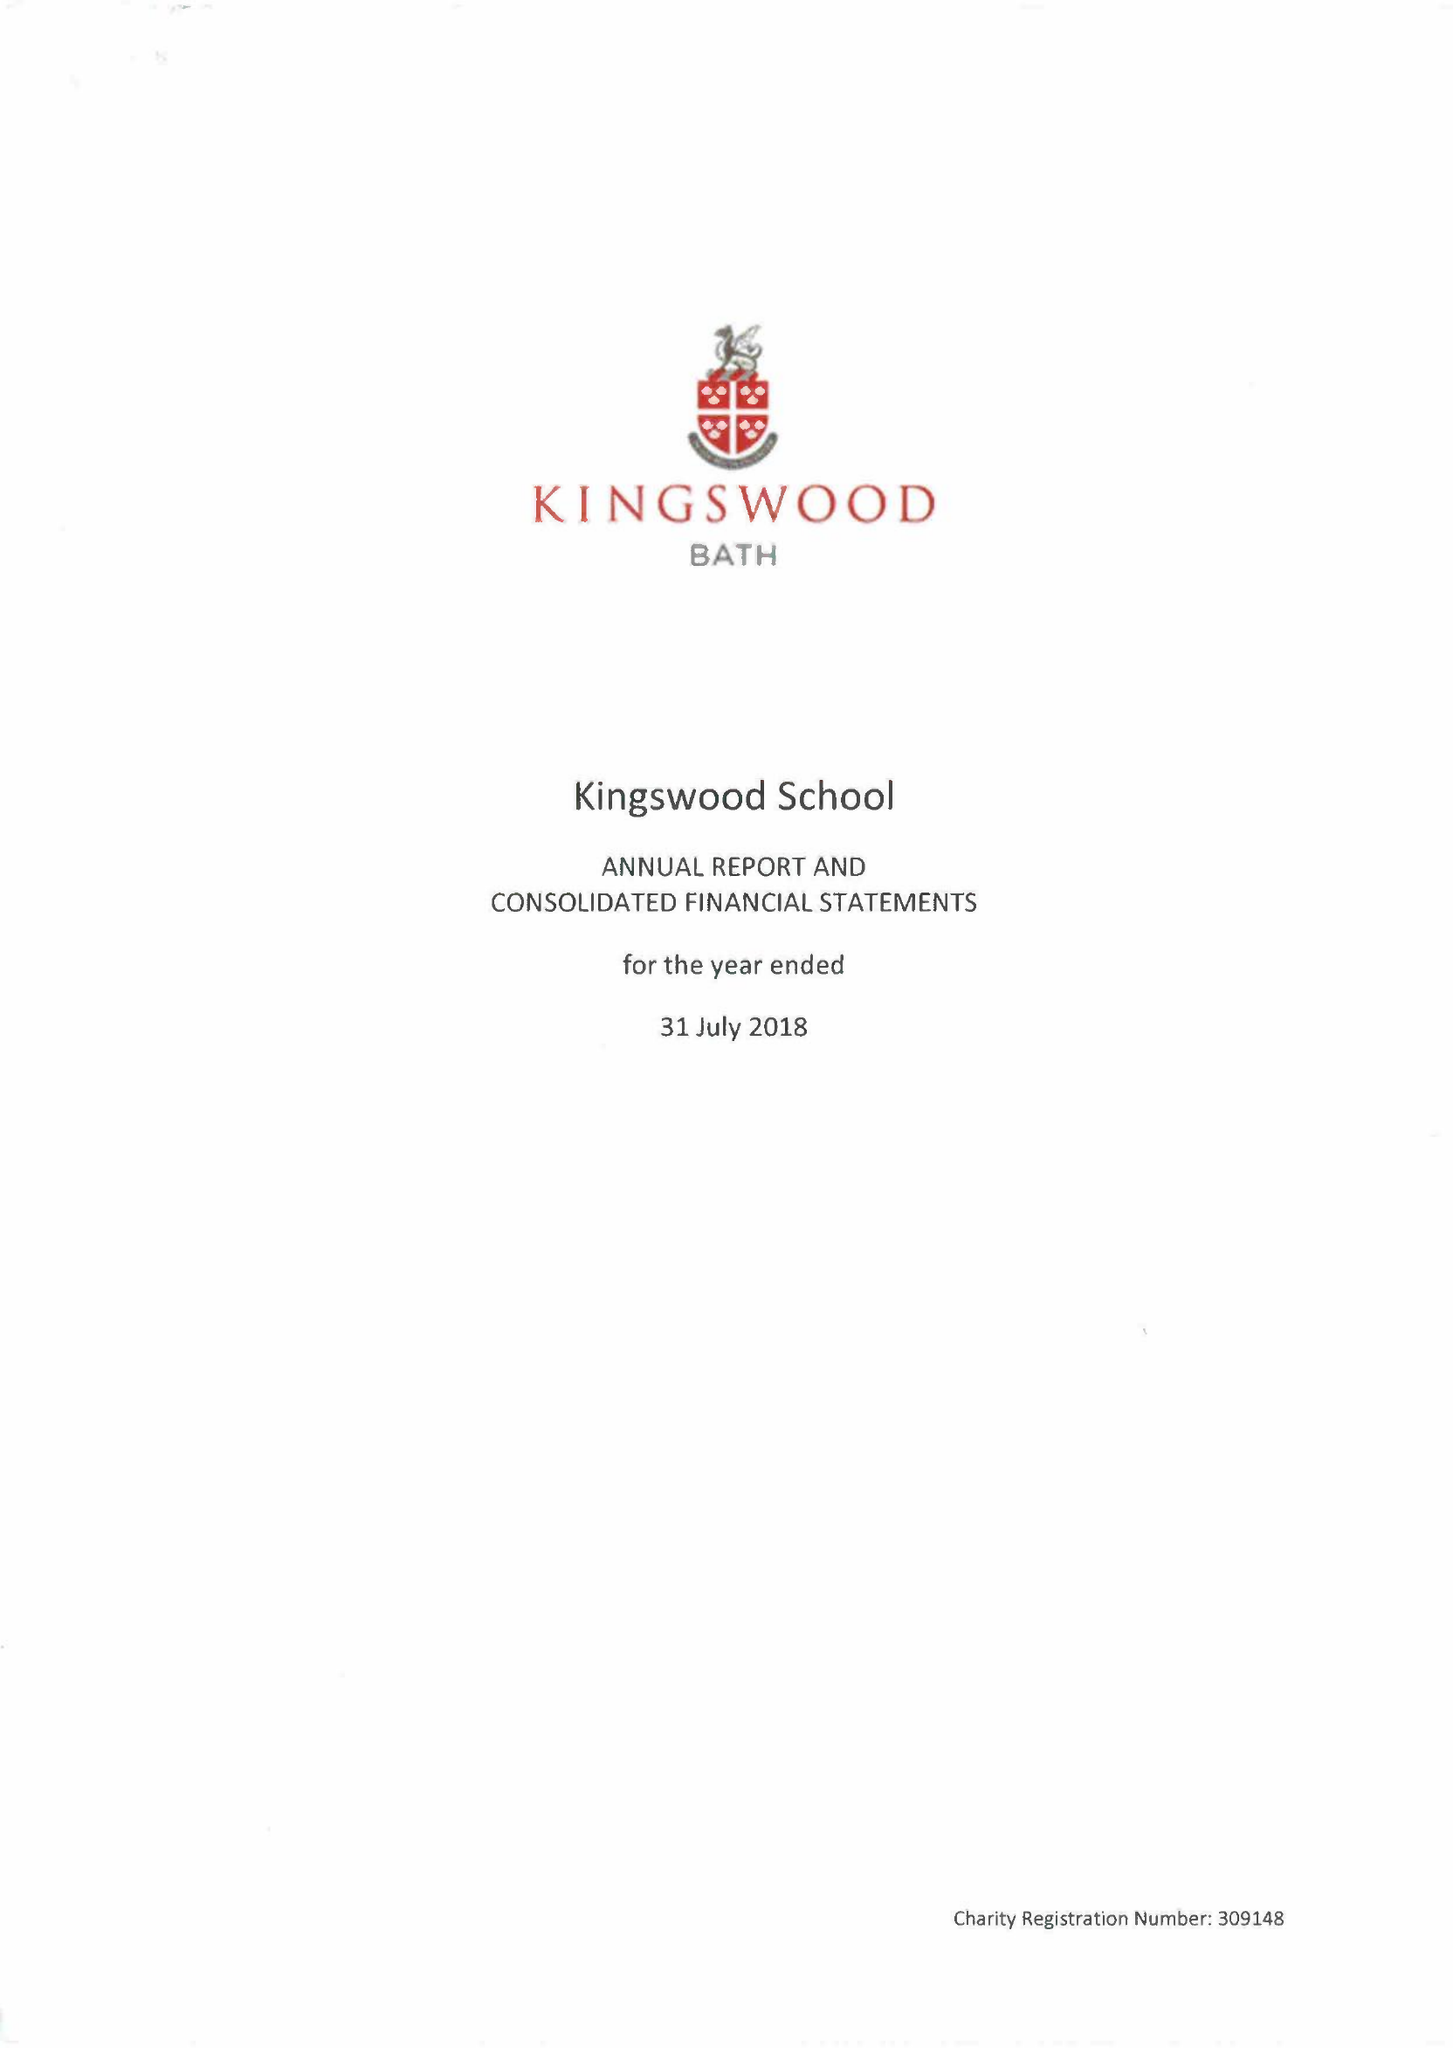What is the value for the address__street_line?
Answer the question using a single word or phrase. LANSDOWN ROAD 